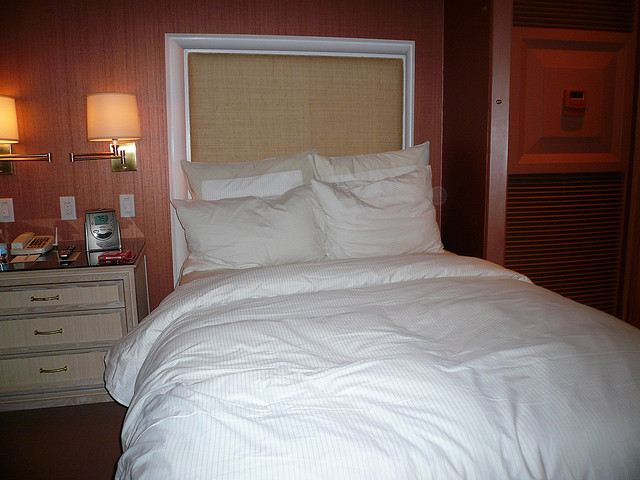How many pillows are there? There are indeed four pillows on the bed, neatly arranged against the headboard, each pillow covered with a crisp, clean white pillowcase that complements the bed's tidy appearance. 